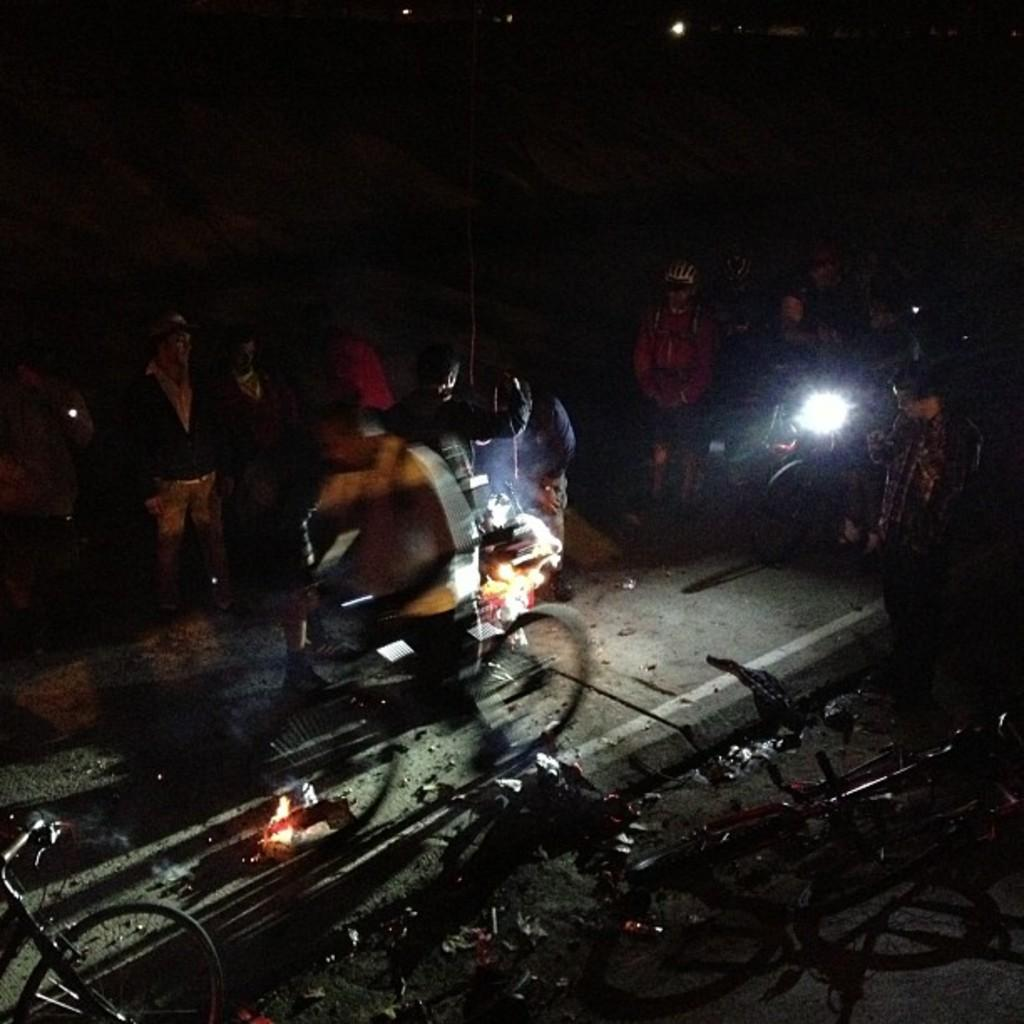Who or what can be seen in the image? There are people in the image. What are the people using in the image? There are bicycles in the image, which suggests that the people might be using them. What is the source of light in the image? There is a torch light in the image, which provides illumination. What other objects can be seen in the image? There are other objects in the image, but their specific details are not mentioned in the provided facts. How would you describe the overall setting of the image? The background of the image is dark, which might indicate that the scene takes place at night or in a dimly lit area. What design is featured on the spy's hat in the image? There is no mention of a spy or a hat in the image, so it is not possible to answer this question. 